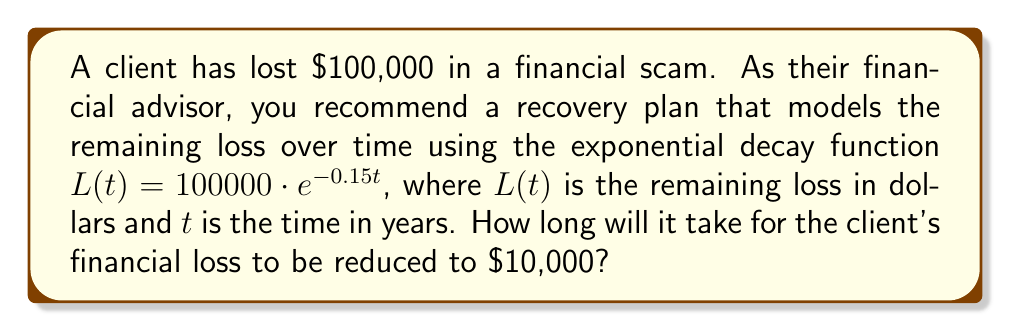Give your solution to this math problem. To solve this problem, we need to use the exponential decay model and solve for time $t$. Let's approach this step-by-step:

1) We start with the given exponential decay function:
   $L(t) = 100000 \cdot e^{-0.15t}$

2) We want to find $t$ when $L(t) = 10000$. So, let's set up the equation:
   $10000 = 100000 \cdot e^{-0.15t}$

3) Divide both sides by 100000:
   $0.1 = e^{-0.15t}$

4) Take the natural logarithm of both sides:
   $\ln(0.1) = \ln(e^{-0.15t})$

5) Simplify the right side using the properties of logarithms:
   $\ln(0.1) = -0.15t$

6) Solve for $t$:
   $t = -\frac{\ln(0.1)}{0.15}$

7) Calculate the value:
   $t = -\frac{-2.30259}{0.15} \approx 15.35$ years

Therefore, it will take approximately 15.35 years for the client's financial loss to be reduced to $10,000.
Answer: 15.35 years 